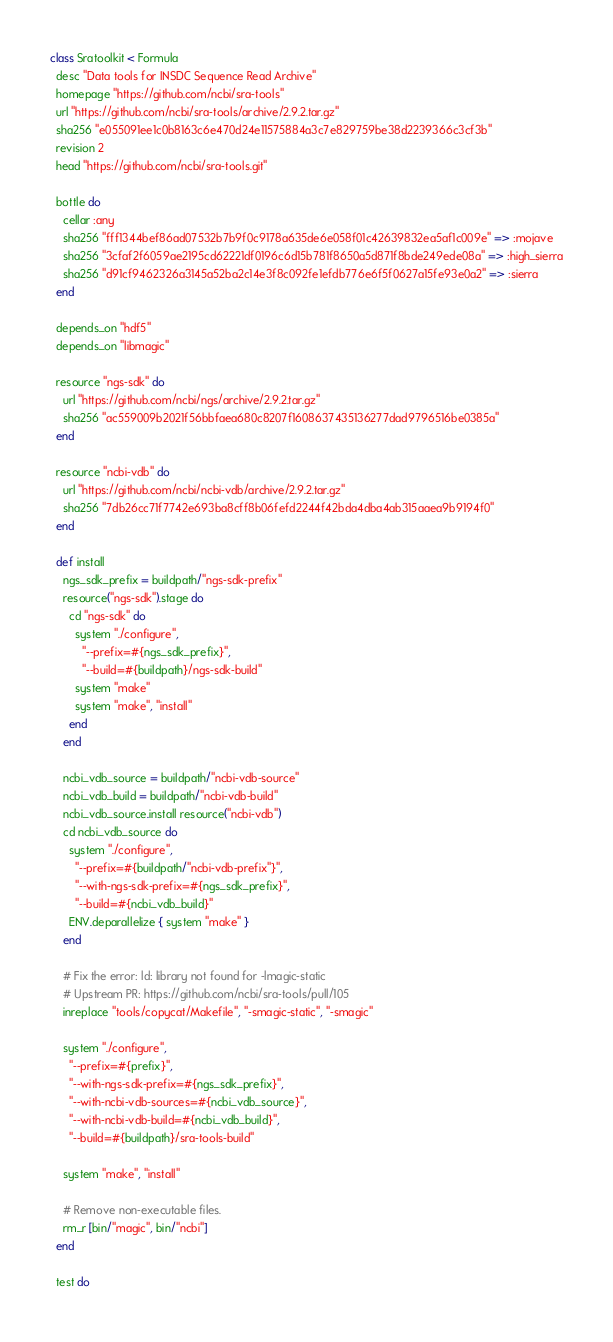Convert code to text. <code><loc_0><loc_0><loc_500><loc_500><_Ruby_>class Sratoolkit < Formula
  desc "Data tools for INSDC Sequence Read Archive"
  homepage "https://github.com/ncbi/sra-tools"
  url "https://github.com/ncbi/sra-tools/archive/2.9.2.tar.gz"
  sha256 "e055091ee1c0b8163c6e470d24e11575884a3c7e829759be38d2239366c3cf3b"
  revision 2
  head "https://github.com/ncbi/sra-tools.git"

  bottle do
    cellar :any
    sha256 "fff1344bef86ad07532b7b9f0c9178a635de6e058f01c42639832ea5af1c009e" => :mojave
    sha256 "3cfaf2f6059ae2195cd62221df0196c6d15b781f8650a5d871f8bde249ede08a" => :high_sierra
    sha256 "d91cf9462326a3145a52ba2c14e3f8c092fe1efdb776e6f5f0627a15fe93e0a2" => :sierra
  end

  depends_on "hdf5"
  depends_on "libmagic"

  resource "ngs-sdk" do
    url "https://github.com/ncbi/ngs/archive/2.9.2.tar.gz"
    sha256 "ac559009b2021f56bbfaea680c8207f1608637435136277dad9796516be0385a"
  end

  resource "ncbi-vdb" do
    url "https://github.com/ncbi/ncbi-vdb/archive/2.9.2.tar.gz"
    sha256 "7db26cc71f7742e693ba8cff8b06fefd2244f42bda4dba4ab315aaea9b9194f0"
  end

  def install
    ngs_sdk_prefix = buildpath/"ngs-sdk-prefix"
    resource("ngs-sdk").stage do
      cd "ngs-sdk" do
        system "./configure",
          "--prefix=#{ngs_sdk_prefix}",
          "--build=#{buildpath}/ngs-sdk-build"
        system "make"
        system "make", "install"
      end
    end

    ncbi_vdb_source = buildpath/"ncbi-vdb-source"
    ncbi_vdb_build = buildpath/"ncbi-vdb-build"
    ncbi_vdb_source.install resource("ncbi-vdb")
    cd ncbi_vdb_source do
      system "./configure",
        "--prefix=#{buildpath/"ncbi-vdb-prefix"}",
        "--with-ngs-sdk-prefix=#{ngs_sdk_prefix}",
        "--build=#{ncbi_vdb_build}"
      ENV.deparallelize { system "make" }
    end

    # Fix the error: ld: library not found for -lmagic-static
    # Upstream PR: https://github.com/ncbi/sra-tools/pull/105
    inreplace "tools/copycat/Makefile", "-smagic-static", "-smagic"

    system "./configure",
      "--prefix=#{prefix}",
      "--with-ngs-sdk-prefix=#{ngs_sdk_prefix}",
      "--with-ncbi-vdb-sources=#{ncbi_vdb_source}",
      "--with-ncbi-vdb-build=#{ncbi_vdb_build}",
      "--build=#{buildpath}/sra-tools-build"

    system "make", "install"

    # Remove non-executable files.
    rm_r [bin/"magic", bin/"ncbi"]
  end

  test do</code> 